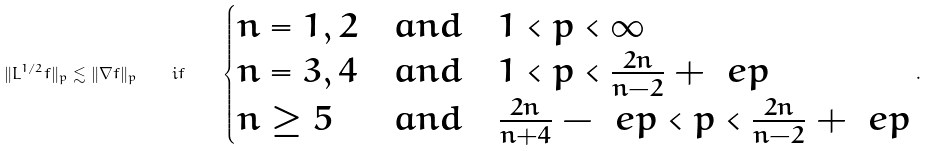<formula> <loc_0><loc_0><loc_500><loc_500>\| L ^ { 1 / 2 } f \| _ { p } \lesssim \| \nabla f \| _ { p } \quad i f \quad \begin{cases} n = 1 , 2 & a n d \quad 1 < p < \infty \\ n = 3 , 4 & a n d \quad 1 < p < \frac { 2 n } { n - 2 } + \ e p \\ n \geq 5 & a n d \quad \frac { 2 n } { n + 4 } - \ e p < p < \frac { 2 n } { n - 2 } + \ e p \end{cases} .</formula> 